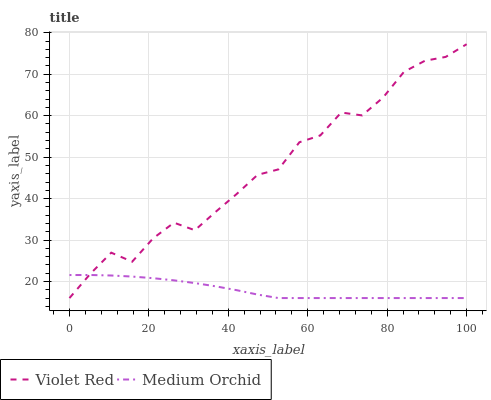Does Medium Orchid have the minimum area under the curve?
Answer yes or no. Yes. Does Violet Red have the maximum area under the curve?
Answer yes or no. Yes. Does Medium Orchid have the maximum area under the curve?
Answer yes or no. No. Is Medium Orchid the smoothest?
Answer yes or no. Yes. Is Violet Red the roughest?
Answer yes or no. Yes. Is Medium Orchid the roughest?
Answer yes or no. No. Does Violet Red have the lowest value?
Answer yes or no. Yes. Does Violet Red have the highest value?
Answer yes or no. Yes. Does Medium Orchid have the highest value?
Answer yes or no. No. Does Violet Red intersect Medium Orchid?
Answer yes or no. Yes. Is Violet Red less than Medium Orchid?
Answer yes or no. No. Is Violet Red greater than Medium Orchid?
Answer yes or no. No. 